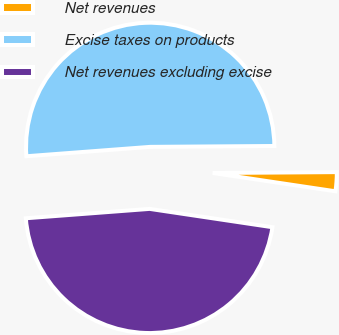Convert chart to OTSL. <chart><loc_0><loc_0><loc_500><loc_500><pie_chart><fcel>Net revenues<fcel>Excise taxes on products<fcel>Net revenues excluding excise<nl><fcel>2.47%<fcel>51.09%<fcel>46.44%<nl></chart> 